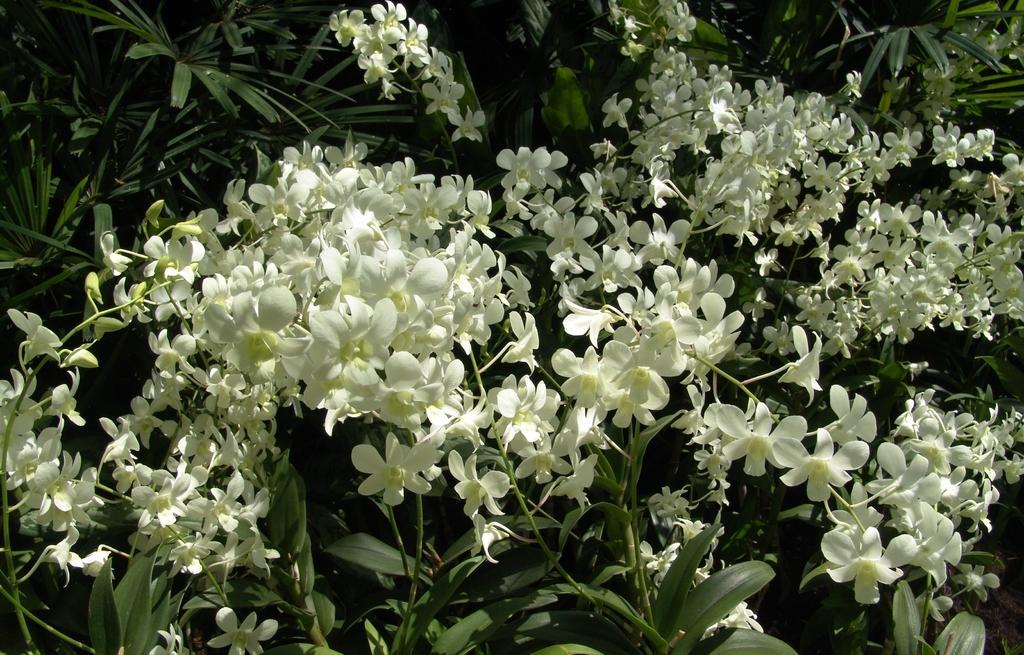How would you summarize this image in a sentence or two? In this image we can see the white color flowers to the plant. 